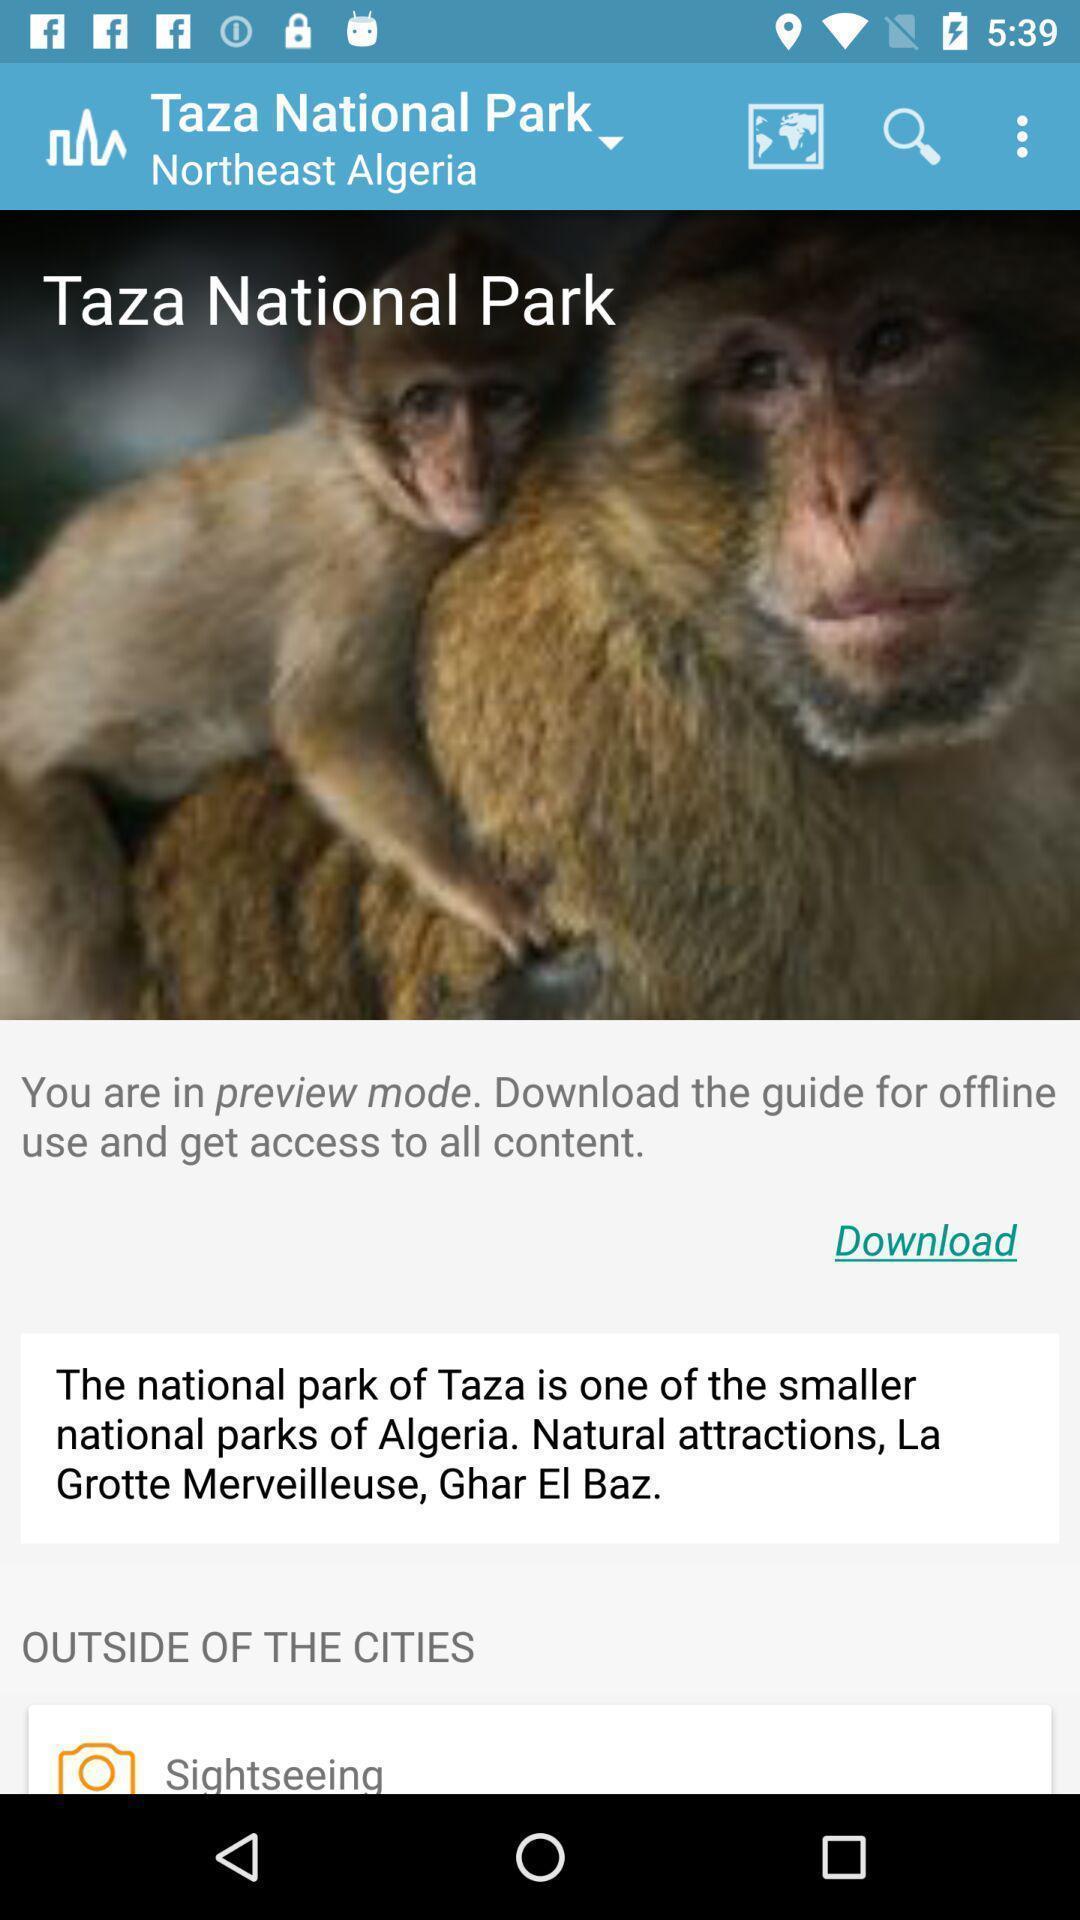Provide a detailed account of this screenshot. Screen shows travel details in a travel application. 